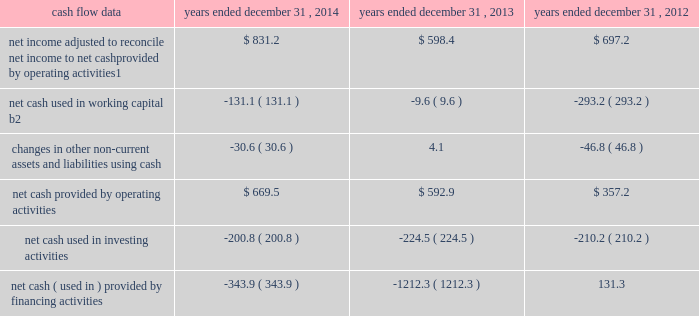Management 2019s discussion and analysis of financial condition and results of operations 2013 ( continued ) ( amounts in millions , except per share amounts ) corporate and other expenses increased slightly during 2013 by $ 3.5 to $ 140.8 compared to 2012 , primarily due to an increase in salaries and related expenses , mainly attributable to higher base salaries , benefits and temporary help , partially offset by lower severance expenses and a decrease in office and general expenses .
Liquidity and capital resources cash flow overview the tables summarize key financial data relating to our liquidity , capital resources and uses of capital. .
1 reflects net income adjusted primarily for depreciation and amortization of fixed assets and intangible assets , amortization of restricted stock and other non-cash compensation , non-cash ( gain ) loss related to early extinguishment of debt , and deferred income taxes .
2 reflects changes in accounts receivable , expenditures billable to clients , other current assets , accounts payable and accrued liabilities .
Operating activities net cash provided by operating activities during 2014 was $ 669.5 , which was an improvement of $ 76.6 as compared to 2013 , primarily as a result of an increase in net income , offset by an increase in working capital usage of $ 121.5 .
Due to the seasonality of our business , we typically generate cash from working capital in the second half of a year and use cash from working capital in the first half of a year , with the largest impacts in the first and fourth quarters .
Our net working capital usage in 2014 was impacted by our media businesses .
Net cash provided by operating activities during 2013 was $ 592.9 , which was an increase of $ 235.7 as compared to 2012 , primarily as a result of an improvement in working capital usage of $ 283.6 , offset by a decrease in net income .
The improvement in working capital in 2013 was impacted by our media businesses and an ongoing focus on working capital management at our agencies .
The timing of media buying on behalf of our clients affects our working capital and operating cash flow .
In most of our businesses , our agencies enter into commitments to pay production and media costs on behalf of clients .
To the extent possible we pay production and media charges after we have received funds from our clients .
The amounts involved substantially exceed our revenues and primarily affect the level of accounts receivable , expenditures billable to clients , accounts payable and accrued liabilities .
Our assets include both cash received and accounts receivable from clients for these pass-through arrangements , while our liabilities include amounts owed on behalf of clients to media and production suppliers .
Our accrued liabilities are also affected by the timing of certain other payments .
For example , while annual cash incentive awards are accrued throughout the year , they are generally paid during the first quarter of the subsequent year .
Investing activities net cash used in investing activities during 2014 primarily related to payments for capital expenditures and acquisitions .
Capital expenditures of $ 148.7 related primarily to computer hardware and software and leasehold improvements .
We made payments of $ 67.8 related to acquisitions completed during 2014 , net of cash acquired. .
What is the growth rate for net cash provided by operating activities from 2013 to 2014? 
Computations: ((669.5 - 592.9) / 592.9)
Answer: 0.1292. 